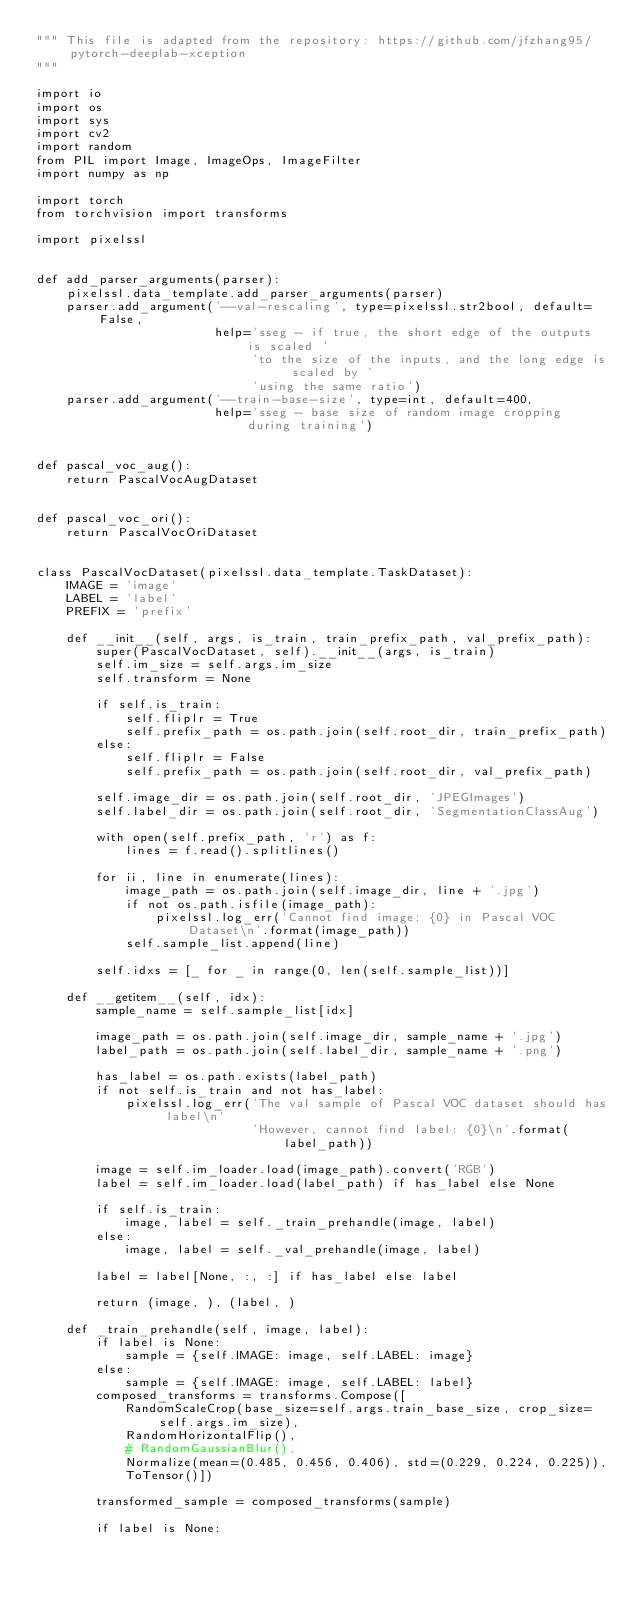Convert code to text. <code><loc_0><loc_0><loc_500><loc_500><_Python_>""" This file is adapted from the repository: https://github.com/jfzhang95/pytorch-deeplab-xception
"""

import io
import os
import sys
import cv2
import random
from PIL import Image, ImageOps, ImageFilter
import numpy as np

import torch
from torchvision import transforms

import pixelssl


def add_parser_arguments(parser):
    pixelssl.data_template.add_parser_arguments(parser)
    parser.add_argument('--val-rescaling', type=pixelssl.str2bool, default=False, 
                        help='sseg - if true, the short edge of the outputs is scaled ' 
                             'to the size of the inputs, and the long edge is scaled by '
                             'using the same ratio')
    parser.add_argument('--train-base-size', type=int, default=400, 
                        help='sseg - base size of random image cropping during training')


def pascal_voc_aug():
    return PascalVocAugDataset


def pascal_voc_ori():
    return PascalVocOriDataset


class PascalVocDataset(pixelssl.data_template.TaskDataset):
    IMAGE = 'image'
    LABEL = 'label'
    PREFIX = 'prefix'

    def __init__(self, args, is_train, train_prefix_path, val_prefix_path):
        super(PascalVocDataset, self).__init__(args, is_train)
        self.im_size = self.args.im_size
        self.transform = None

        if self.is_train:
            self.fliplr = True
            self.prefix_path = os.path.join(self.root_dir, train_prefix_path)
        else:
            self.fliplr = False
            self.prefix_path = os.path.join(self.root_dir, val_prefix_path)

        self.image_dir = os.path.join(self.root_dir, 'JPEGImages')
        self.label_dir = os.path.join(self.root_dir, 'SegmentationClassAug')

        with open(self.prefix_path, 'r') as f:
            lines = f.read().splitlines()
        
        for ii, line in enumerate(lines):
            image_path = os.path.join(self.image_dir, line + '.jpg')
            if not os.path.isfile(image_path):
                pixelssl.log_err('Cannot find image: {0} in Pascal VOC Dataset\n'.format(image_path))
            self.sample_list.append(line)

        self.idxs = [_ for _ in range(0, len(self.sample_list))]

    def __getitem__(self, idx):
        sample_name = self.sample_list[idx]

        image_path = os.path.join(self.image_dir, sample_name + '.jpg')
        label_path = os.path.join(self.label_dir, sample_name + '.png')

        has_label = os.path.exists(label_path)
        if not self.is_train and not has_label:
            pixelssl.log_err('The val sample of Pascal VOC dataset should has label\n'
                             'However, cannot find label: {0}\n'.format(label_path))

        image = self.im_loader.load(image_path).convert('RGB')
        label = self.im_loader.load(label_path) if has_label else None
        
        if self.is_train:
            image, label = self._train_prehandle(image, label)
        else:
            image, label = self._val_prehandle(image, label)

        label = label[None, :, :] if has_label else label

        return (image, ), (label, )

    def _train_prehandle(self, image, label):
        if label is None:
            sample = {self.IMAGE: image, self.LABEL: image} 
        else:
            sample = {self.IMAGE: image, self.LABEL: label}
        composed_transforms = transforms.Compose([
            RandomScaleCrop(base_size=self.args.train_base_size, crop_size=self.args.im_size),
            RandomHorizontalFlip(),
            # RandomGaussianBlur(),
            Normalize(mean=(0.485, 0.456, 0.406), std=(0.229, 0.224, 0.225)),
            ToTensor()])

        transformed_sample = composed_transforms(sample)

        if label is None:</code> 